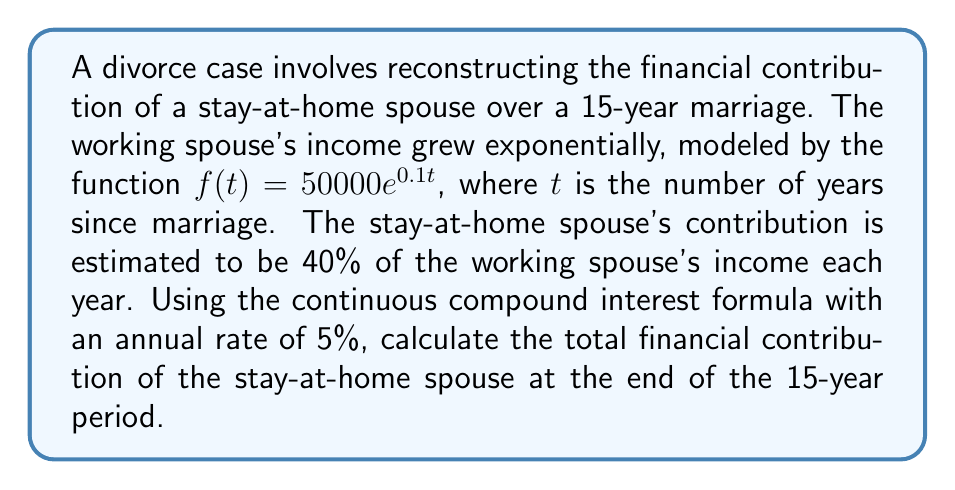Show me your answer to this math problem. 1) First, we need to set up the integral that represents the stay-at-home spouse's contribution over time:

   $$C = \int_0^{15} 0.4 \cdot 50000e^{0.1t} \cdot e^{0.05(15-t)} dt$$

   Here, $0.4 \cdot 50000e^{0.1t}$ is the contribution at time $t$, and $e^{0.05(15-t)}$ is the growth factor for that contribution until the end of the 15-year period.

2) Simplify the integral:

   $$C = 20000 \int_0^{15} e^{0.1t} \cdot e^{0.05(15-t)} dt$$
   $$C = 20000e^{0.75} \int_0^{15} e^{0.05t} dt$$

3) Evaluate the integral:

   $$C = 20000e^{0.75} \cdot \frac{1}{0.05}[e^{0.05t}]_0^{15}$$
   $$C = 400000e^{0.75} \cdot (e^{0.75} - 1)$$

4) Calculate the final value:

   $$C = 400000 \cdot 2.117 \cdot 1.117$$
   $$C = 944,276.76$$
Answer: $944,276.76 